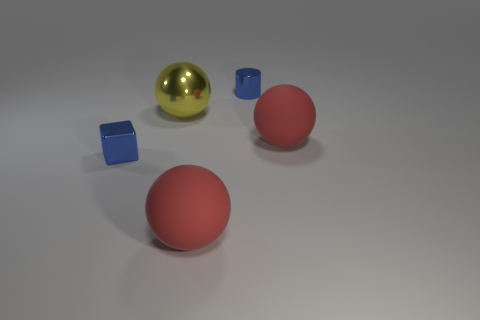There is a tiny shiny thing on the left side of the cylinder; is it the same shape as the big metal thing?
Offer a very short reply. No. There is a tiny thing that is behind the metallic thing that is in front of the large yellow ball; what is its shape?
Make the answer very short. Cylinder. How big is the blue thing that is to the right of the large yellow shiny object behind the tiny metal thing in front of the metal cylinder?
Ensure brevity in your answer.  Small. Do the metallic sphere and the metal block have the same size?
Your response must be concise. No. There is a tiny thing to the right of the large yellow shiny sphere; what is it made of?
Offer a very short reply. Metal. What number of other things are the same shape as the yellow object?
Offer a very short reply. 2. Are there any yellow shiny objects in front of the large shiny ball?
Your answer should be compact. No. How many objects are either big green spheres or yellow metallic objects?
Provide a short and direct response. 1. What number of other objects are the same size as the blue metallic cylinder?
Your answer should be compact. 1. What number of small blue objects are both behind the large yellow ball and in front of the blue cylinder?
Offer a very short reply. 0. 